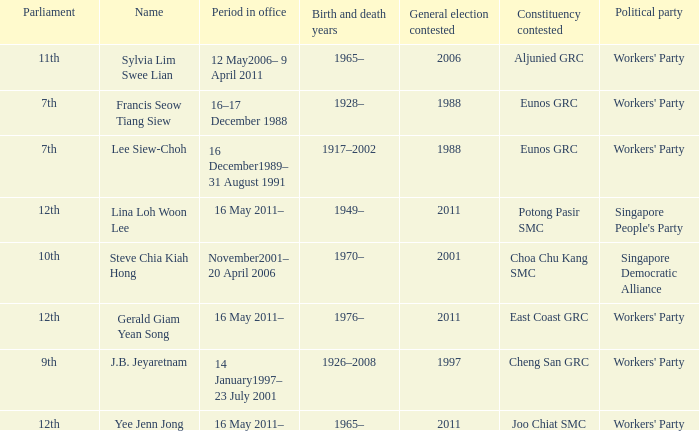What number parliament held it's election in 1997? 9th. 